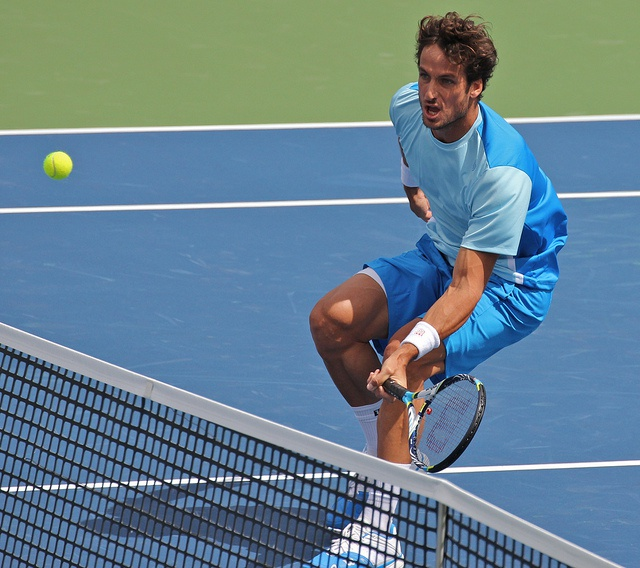Describe the objects in this image and their specific colors. I can see people in olive, gray, blue, maroon, and black tones, tennis racket in olive, gray, and black tones, and sports ball in olive, khaki, and yellow tones in this image. 